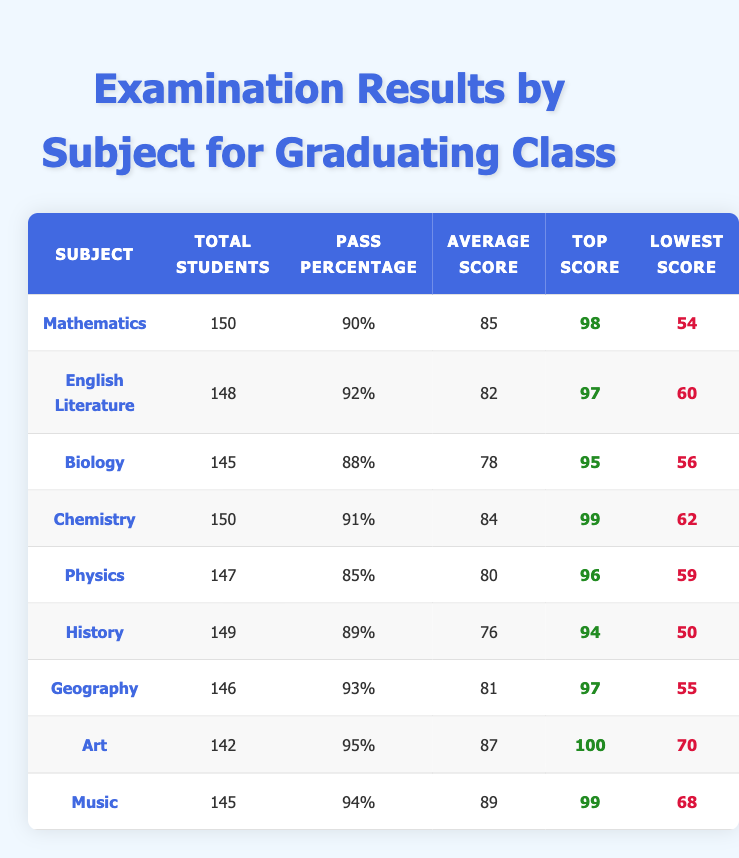What is the pass percentage for Mathematics? The pass percentage for Mathematics can be directly found in the table under the relevant column, which shows 90%.
Answer: 90% What is the top score in Art? The top score for Art is also listed in the table, and it shows a value of 100.
Answer: 100 Which subject has the lowest pass percentage? By comparing the pass percentages across subjects, Physics has the lowest at 85%.
Answer: Physics What is the average score for English Literature? The average score for English Literature is directly shown in the table as 82.
Answer: 82 How many students passed Chemistry? To find the number of students who passed Chemistry, we calculate: 91% of 150 students, which is (150 * 0.91) = 136.5, rounding down gives us 136 students.
Answer: 136 What are the total students and average score for Geography? The total students for Geography is 146 and the average score is 81, both values are directly shown in the table.
Answer: 146 students and average score of 81 What is the difference between the top score in Music and the lowest score in Biology? The top score in Music is 99, and the lowest score in Biology is 56. Therefore, the difference is 99 - 56 = 43.
Answer: 43 Which subjects have a pass percentage greater than 90%? Looking at the pass percentages, Mathematics (90%), English Literature (92%), Chemistry (91%), Geography (93%), and Art (95%) all exceed 90%.
Answer: Mathematics, English Literature, Chemistry, Geography, Art What is the average of the average scores for all subjects? To calculate the average of the average scores, we sum all average scores (85+82+78+84+80+76+81+87+89 =  325) and divide by the number of subjects (9), resulting in 325/9 ≈ 80.56.
Answer: Approximately 80.56 Is the top score in Physics greater than the top score in Biology? The top score in Physics is 96, while in Biology it’s 95. Since 96 is greater than 95, the statement is true.
Answer: Yes 